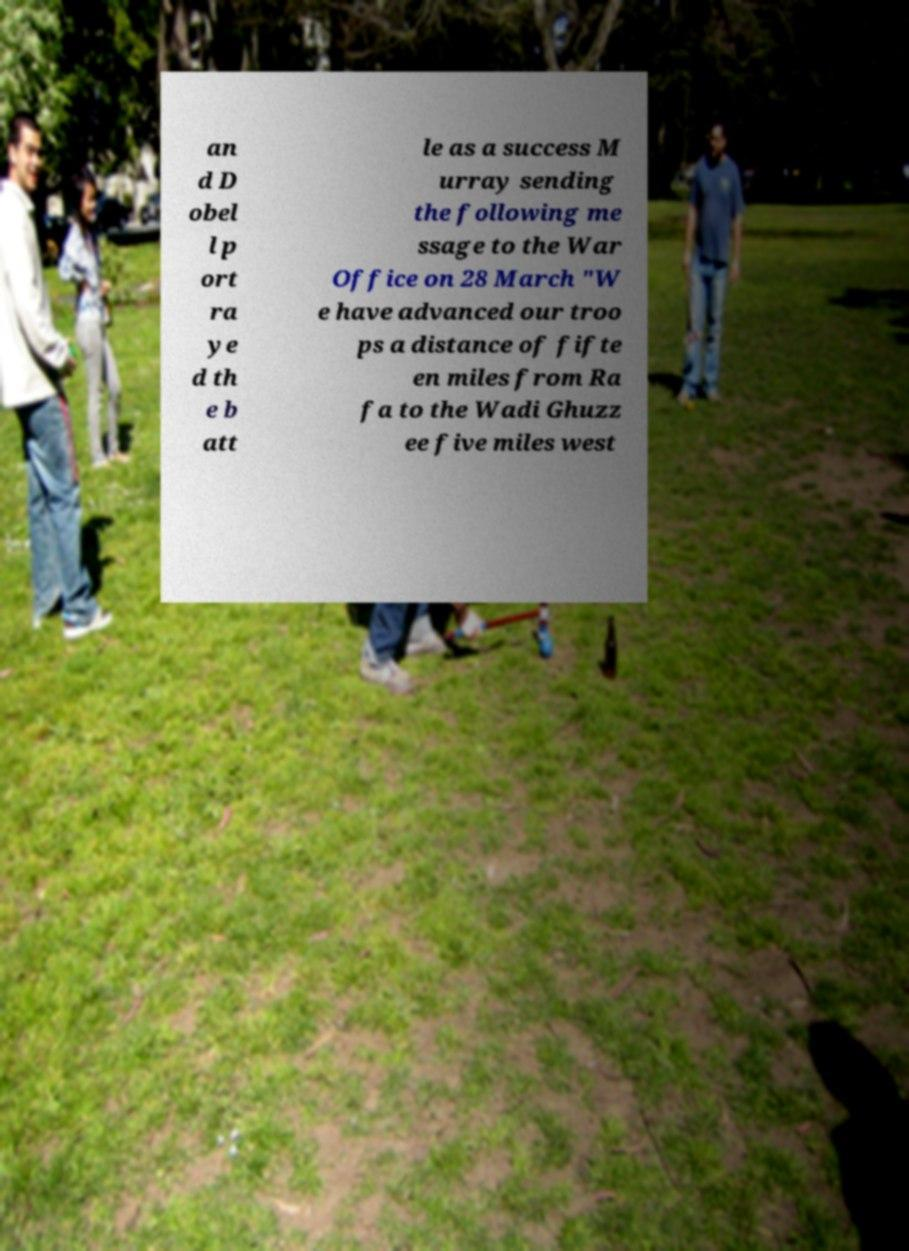Could you assist in decoding the text presented in this image and type it out clearly? an d D obel l p ort ra ye d th e b att le as a success M urray sending the following me ssage to the War Office on 28 March "W e have advanced our troo ps a distance of fifte en miles from Ra fa to the Wadi Ghuzz ee five miles west 